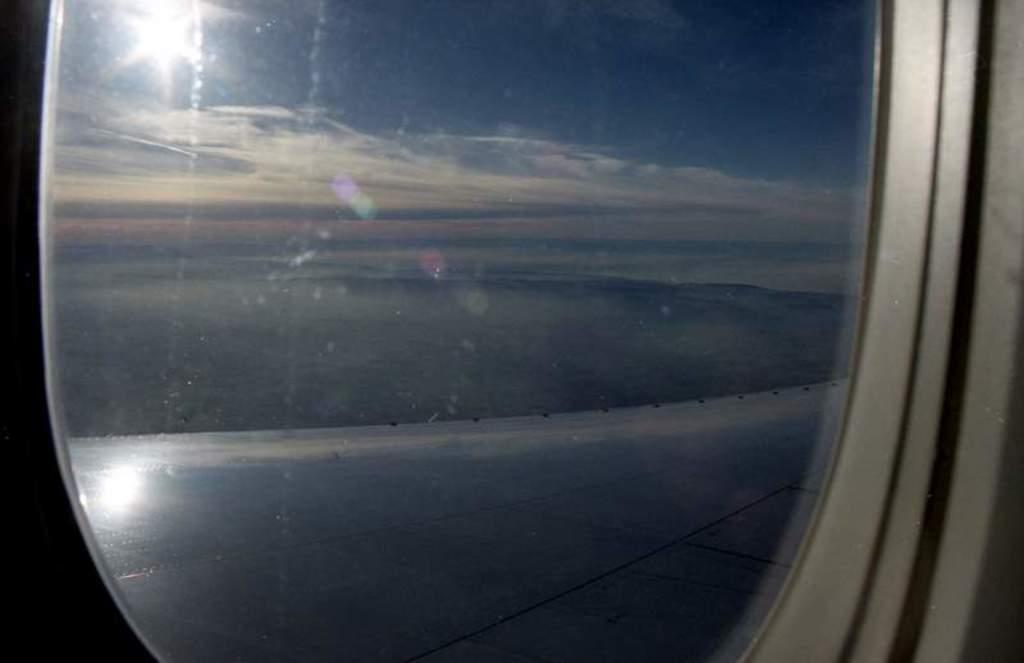What is the main subject of the image? The main subject of the image is a window of an airplane. What can be seen outside the airplane window? There is a runway visible in the image. What is visible in the background of the image? The sky is visible in the background of the image. What can be observed about the sky in the image? There are clouds and the sun visible in the sky. How many houses can be seen in the image? There are no houses visible in the image; it features a window of an airplane with a view of a runway and the sky. Is there a donkey present in the image? No, there is no donkey present in the image. 